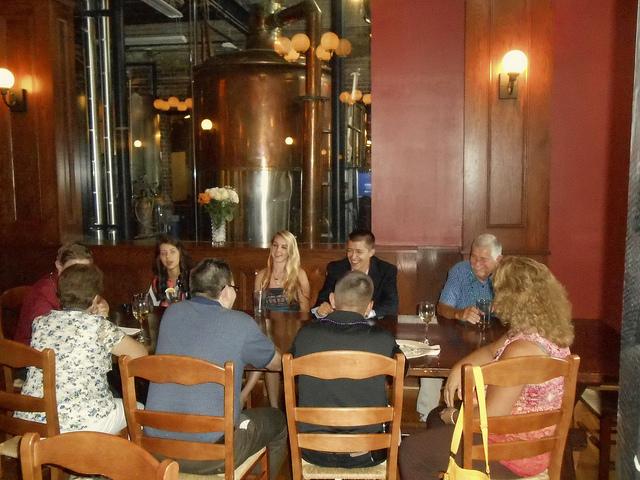How many children do you see?
Short answer required. 0. How many people are sitting down?
Keep it brief. 9. What kind of lights are behind the people?
Quick response, please. Sunlight. 